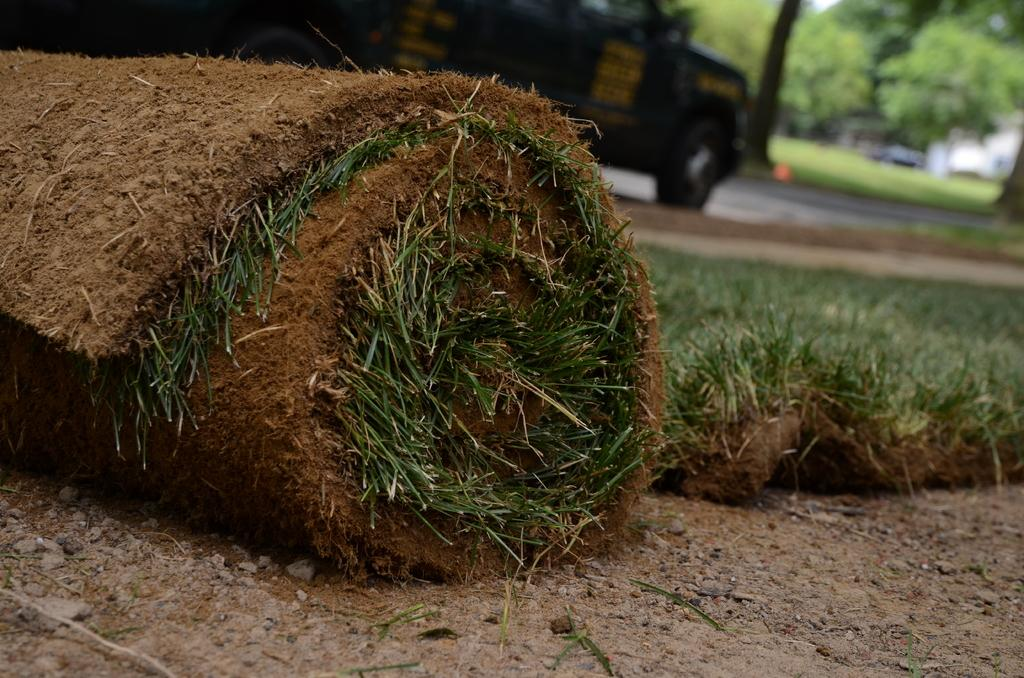What type of natural feature is present in the image? There is a roll of grass in the image. What type of surface is the roll of grass placed on? The floor is made of sand. What type of transportation is visible in the image? There is a vehicle in the image. What type of plant life can be seen in the image? There are trees in the image. Where is the arch located in the image? There is no arch present in the image. Can you describe the snake that is slithering through the trees in the image? There is no snake present in the image; only a roll of grass, sand floor, a vehicle, and trees are visible. 